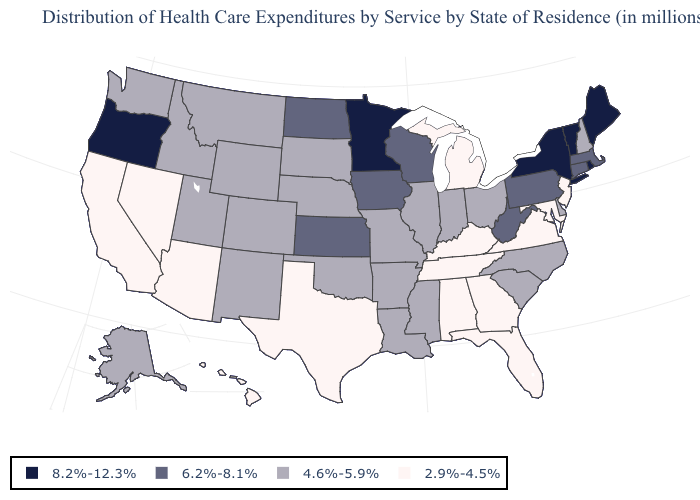Does Oregon have the lowest value in the USA?
Give a very brief answer. No. Name the states that have a value in the range 6.2%-8.1%?
Answer briefly. Connecticut, Iowa, Kansas, Massachusetts, North Dakota, Pennsylvania, West Virginia, Wisconsin. Is the legend a continuous bar?
Quick response, please. No. Among the states that border New Mexico , does Texas have the lowest value?
Quick response, please. Yes. Does Nebraska have the highest value in the MidWest?
Short answer required. No. Among the states that border Oregon , does Washington have the highest value?
Give a very brief answer. Yes. Does Maine have the highest value in the USA?
Answer briefly. Yes. What is the value of Oregon?
Give a very brief answer. 8.2%-12.3%. Which states have the highest value in the USA?
Be succinct. Maine, Minnesota, New York, Oregon, Rhode Island, Vermont. Name the states that have a value in the range 8.2%-12.3%?
Keep it brief. Maine, Minnesota, New York, Oregon, Rhode Island, Vermont. Name the states that have a value in the range 2.9%-4.5%?
Answer briefly. Alabama, Arizona, California, Florida, Georgia, Hawaii, Kentucky, Maryland, Michigan, Nevada, New Jersey, Tennessee, Texas, Virginia. Does the first symbol in the legend represent the smallest category?
Quick response, please. No. What is the lowest value in states that border South Carolina?
Answer briefly. 2.9%-4.5%. Which states have the lowest value in the USA?
Keep it brief. Alabama, Arizona, California, Florida, Georgia, Hawaii, Kentucky, Maryland, Michigan, Nevada, New Jersey, Tennessee, Texas, Virginia. Name the states that have a value in the range 4.6%-5.9%?
Give a very brief answer. Alaska, Arkansas, Colorado, Delaware, Idaho, Illinois, Indiana, Louisiana, Mississippi, Missouri, Montana, Nebraska, New Hampshire, New Mexico, North Carolina, Ohio, Oklahoma, South Carolina, South Dakota, Utah, Washington, Wyoming. 